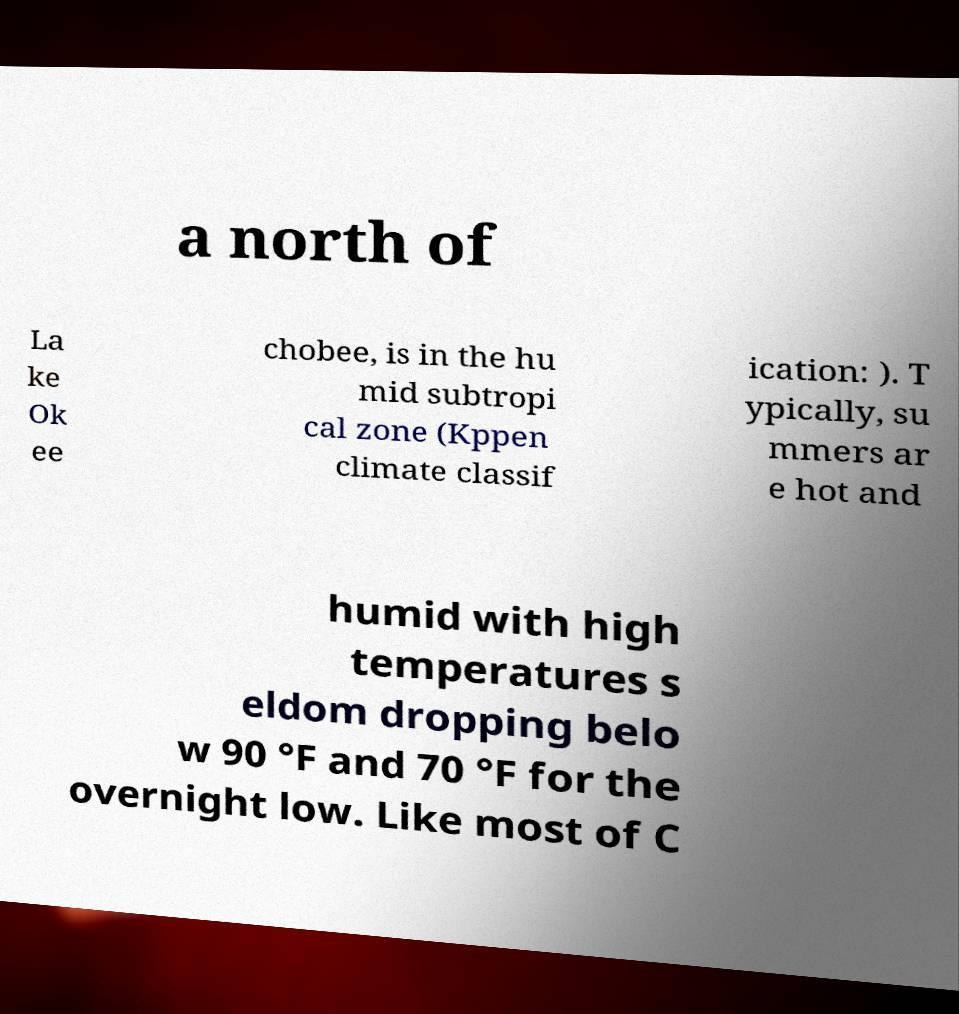Could you assist in decoding the text presented in this image and type it out clearly? a north of La ke Ok ee chobee, is in the hu mid subtropi cal zone (Kppen climate classif ication: ). T ypically, su mmers ar e hot and humid with high temperatures s eldom dropping belo w 90 °F and 70 °F for the overnight low. Like most of C 